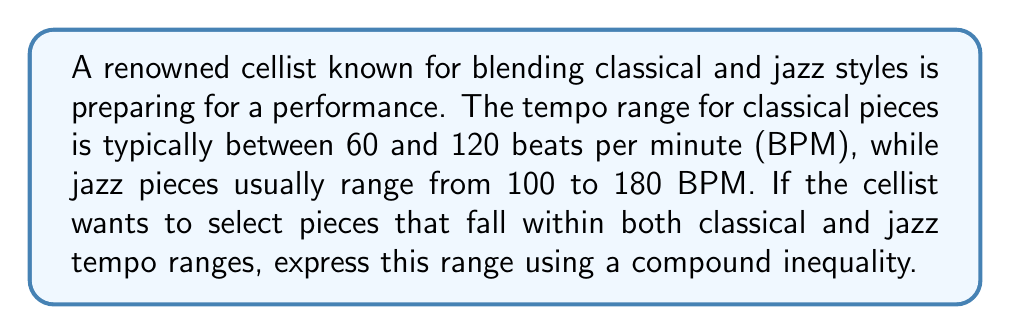Give your solution to this math problem. To solve this problem, we need to find the overlapping range between classical and jazz tempos:

1. Classical tempo range: $60 \leq x \leq 120$ (where $x$ is the tempo in BPM)
2. Jazz tempo range: $100 \leq x \leq 180$

The overlapping range will start at the higher of the two lower bounds (100 BPM) and end at the lower of the two upper bounds (120 BPM).

Therefore, the range that satisfies both classical and jazz tempo ranges can be expressed as:

$$100 \leq x \leq 120$$

This compound inequality represents the tempo range where the cellist can select pieces that fit both classical and jazz styles.
Answer: $100 \leq x \leq 120$ 